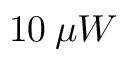Convert formula to latex. <formula><loc_0><loc_0><loc_500><loc_500>1 0 \, \mu W</formula> 